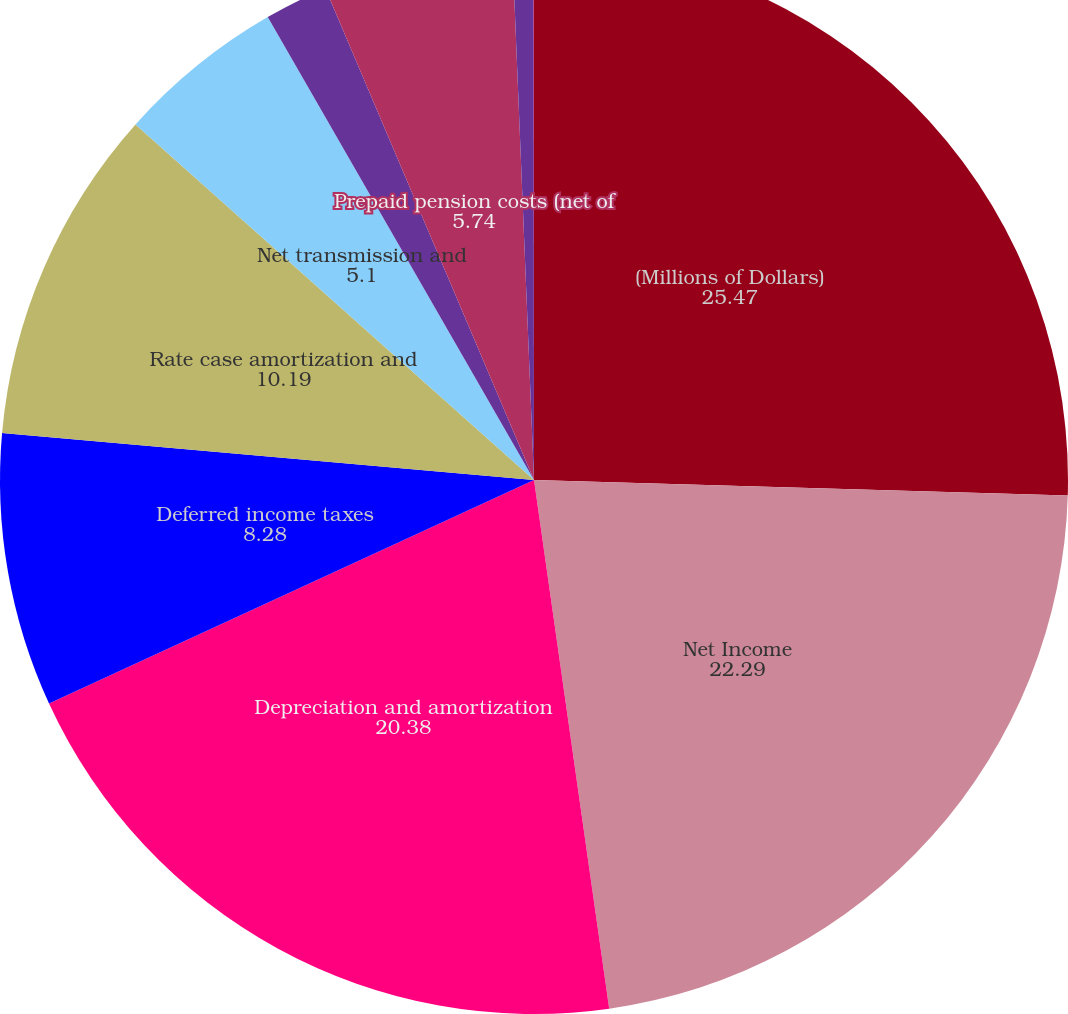Convert chart to OTSL. <chart><loc_0><loc_0><loc_500><loc_500><pie_chart><fcel>(Millions of Dollars)<fcel>Net Income<fcel>Depreciation and amortization<fcel>Deferred income taxes<fcel>Rate case amortization and<fcel>Net transmission and<fcel>Common equity component of<fcel>Prepaid pension costs (net of<fcel>Net derivative losses<fcel>Other non-cash items (net)<nl><fcel>25.47%<fcel>22.29%<fcel>20.38%<fcel>8.28%<fcel>10.19%<fcel>5.1%<fcel>1.92%<fcel>5.74%<fcel>0.64%<fcel>0.01%<nl></chart> 